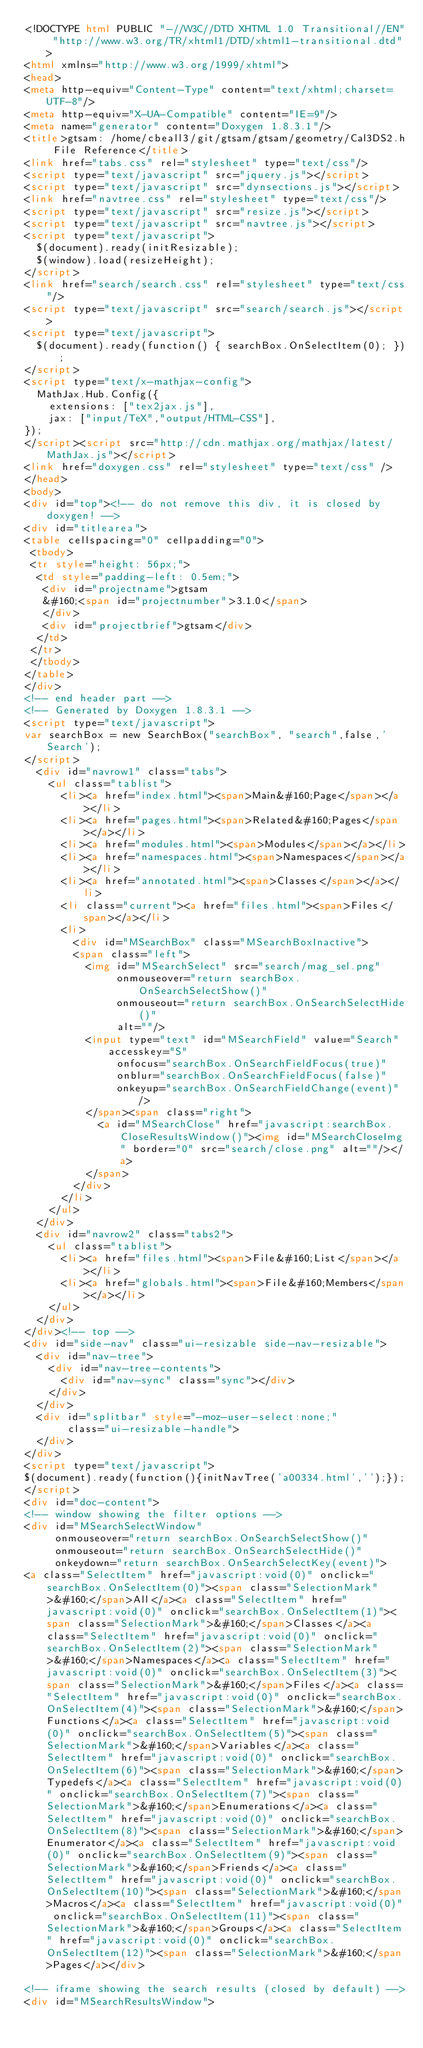Convert code to text. <code><loc_0><loc_0><loc_500><loc_500><_HTML_><!DOCTYPE html PUBLIC "-//W3C//DTD XHTML 1.0 Transitional//EN" "http://www.w3.org/TR/xhtml1/DTD/xhtml1-transitional.dtd">
<html xmlns="http://www.w3.org/1999/xhtml">
<head>
<meta http-equiv="Content-Type" content="text/xhtml;charset=UTF-8"/>
<meta http-equiv="X-UA-Compatible" content="IE=9"/>
<meta name="generator" content="Doxygen 1.8.3.1"/>
<title>gtsam: /home/cbeall3/git/gtsam/gtsam/geometry/Cal3DS2.h File Reference</title>
<link href="tabs.css" rel="stylesheet" type="text/css"/>
<script type="text/javascript" src="jquery.js"></script>
<script type="text/javascript" src="dynsections.js"></script>
<link href="navtree.css" rel="stylesheet" type="text/css"/>
<script type="text/javascript" src="resize.js"></script>
<script type="text/javascript" src="navtree.js"></script>
<script type="text/javascript">
  $(document).ready(initResizable);
  $(window).load(resizeHeight);
</script>
<link href="search/search.css" rel="stylesheet" type="text/css"/>
<script type="text/javascript" src="search/search.js"></script>
<script type="text/javascript">
  $(document).ready(function() { searchBox.OnSelectItem(0); });
</script>
<script type="text/x-mathjax-config">
  MathJax.Hub.Config({
    extensions: ["tex2jax.js"],
    jax: ["input/TeX","output/HTML-CSS"],
});
</script><script src="http://cdn.mathjax.org/mathjax/latest/MathJax.js"></script>
<link href="doxygen.css" rel="stylesheet" type="text/css" />
</head>
<body>
<div id="top"><!-- do not remove this div, it is closed by doxygen! -->
<div id="titlearea">
<table cellspacing="0" cellpadding="0">
 <tbody>
 <tr style="height: 56px;">
  <td style="padding-left: 0.5em;">
   <div id="projectname">gtsam
   &#160;<span id="projectnumber">3.1.0</span>
   </div>
   <div id="projectbrief">gtsam</div>
  </td>
 </tr>
 </tbody>
</table>
</div>
<!-- end header part -->
<!-- Generated by Doxygen 1.8.3.1 -->
<script type="text/javascript">
var searchBox = new SearchBox("searchBox", "search",false,'Search');
</script>
  <div id="navrow1" class="tabs">
    <ul class="tablist">
      <li><a href="index.html"><span>Main&#160;Page</span></a></li>
      <li><a href="pages.html"><span>Related&#160;Pages</span></a></li>
      <li><a href="modules.html"><span>Modules</span></a></li>
      <li><a href="namespaces.html"><span>Namespaces</span></a></li>
      <li><a href="annotated.html"><span>Classes</span></a></li>
      <li class="current"><a href="files.html"><span>Files</span></a></li>
      <li>
        <div id="MSearchBox" class="MSearchBoxInactive">
        <span class="left">
          <img id="MSearchSelect" src="search/mag_sel.png"
               onmouseover="return searchBox.OnSearchSelectShow()"
               onmouseout="return searchBox.OnSearchSelectHide()"
               alt=""/>
          <input type="text" id="MSearchField" value="Search" accesskey="S"
               onfocus="searchBox.OnSearchFieldFocus(true)" 
               onblur="searchBox.OnSearchFieldFocus(false)" 
               onkeyup="searchBox.OnSearchFieldChange(event)"/>
          </span><span class="right">
            <a id="MSearchClose" href="javascript:searchBox.CloseResultsWindow()"><img id="MSearchCloseImg" border="0" src="search/close.png" alt=""/></a>
          </span>
        </div>
      </li>
    </ul>
  </div>
  <div id="navrow2" class="tabs2">
    <ul class="tablist">
      <li><a href="files.html"><span>File&#160;List</span></a></li>
      <li><a href="globals.html"><span>File&#160;Members</span></a></li>
    </ul>
  </div>
</div><!-- top -->
<div id="side-nav" class="ui-resizable side-nav-resizable">
  <div id="nav-tree">
    <div id="nav-tree-contents">
      <div id="nav-sync" class="sync"></div>
    </div>
  </div>
  <div id="splitbar" style="-moz-user-select:none;" 
       class="ui-resizable-handle">
  </div>
</div>
<script type="text/javascript">
$(document).ready(function(){initNavTree('a00334.html','');});
</script>
<div id="doc-content">
<!-- window showing the filter options -->
<div id="MSearchSelectWindow"
     onmouseover="return searchBox.OnSearchSelectShow()"
     onmouseout="return searchBox.OnSearchSelectHide()"
     onkeydown="return searchBox.OnSearchSelectKey(event)">
<a class="SelectItem" href="javascript:void(0)" onclick="searchBox.OnSelectItem(0)"><span class="SelectionMark">&#160;</span>All</a><a class="SelectItem" href="javascript:void(0)" onclick="searchBox.OnSelectItem(1)"><span class="SelectionMark">&#160;</span>Classes</a><a class="SelectItem" href="javascript:void(0)" onclick="searchBox.OnSelectItem(2)"><span class="SelectionMark">&#160;</span>Namespaces</a><a class="SelectItem" href="javascript:void(0)" onclick="searchBox.OnSelectItem(3)"><span class="SelectionMark">&#160;</span>Files</a><a class="SelectItem" href="javascript:void(0)" onclick="searchBox.OnSelectItem(4)"><span class="SelectionMark">&#160;</span>Functions</a><a class="SelectItem" href="javascript:void(0)" onclick="searchBox.OnSelectItem(5)"><span class="SelectionMark">&#160;</span>Variables</a><a class="SelectItem" href="javascript:void(0)" onclick="searchBox.OnSelectItem(6)"><span class="SelectionMark">&#160;</span>Typedefs</a><a class="SelectItem" href="javascript:void(0)" onclick="searchBox.OnSelectItem(7)"><span class="SelectionMark">&#160;</span>Enumerations</a><a class="SelectItem" href="javascript:void(0)" onclick="searchBox.OnSelectItem(8)"><span class="SelectionMark">&#160;</span>Enumerator</a><a class="SelectItem" href="javascript:void(0)" onclick="searchBox.OnSelectItem(9)"><span class="SelectionMark">&#160;</span>Friends</a><a class="SelectItem" href="javascript:void(0)" onclick="searchBox.OnSelectItem(10)"><span class="SelectionMark">&#160;</span>Macros</a><a class="SelectItem" href="javascript:void(0)" onclick="searchBox.OnSelectItem(11)"><span class="SelectionMark">&#160;</span>Groups</a><a class="SelectItem" href="javascript:void(0)" onclick="searchBox.OnSelectItem(12)"><span class="SelectionMark">&#160;</span>Pages</a></div>

<!-- iframe showing the search results (closed by default) -->
<div id="MSearchResultsWindow"></code> 